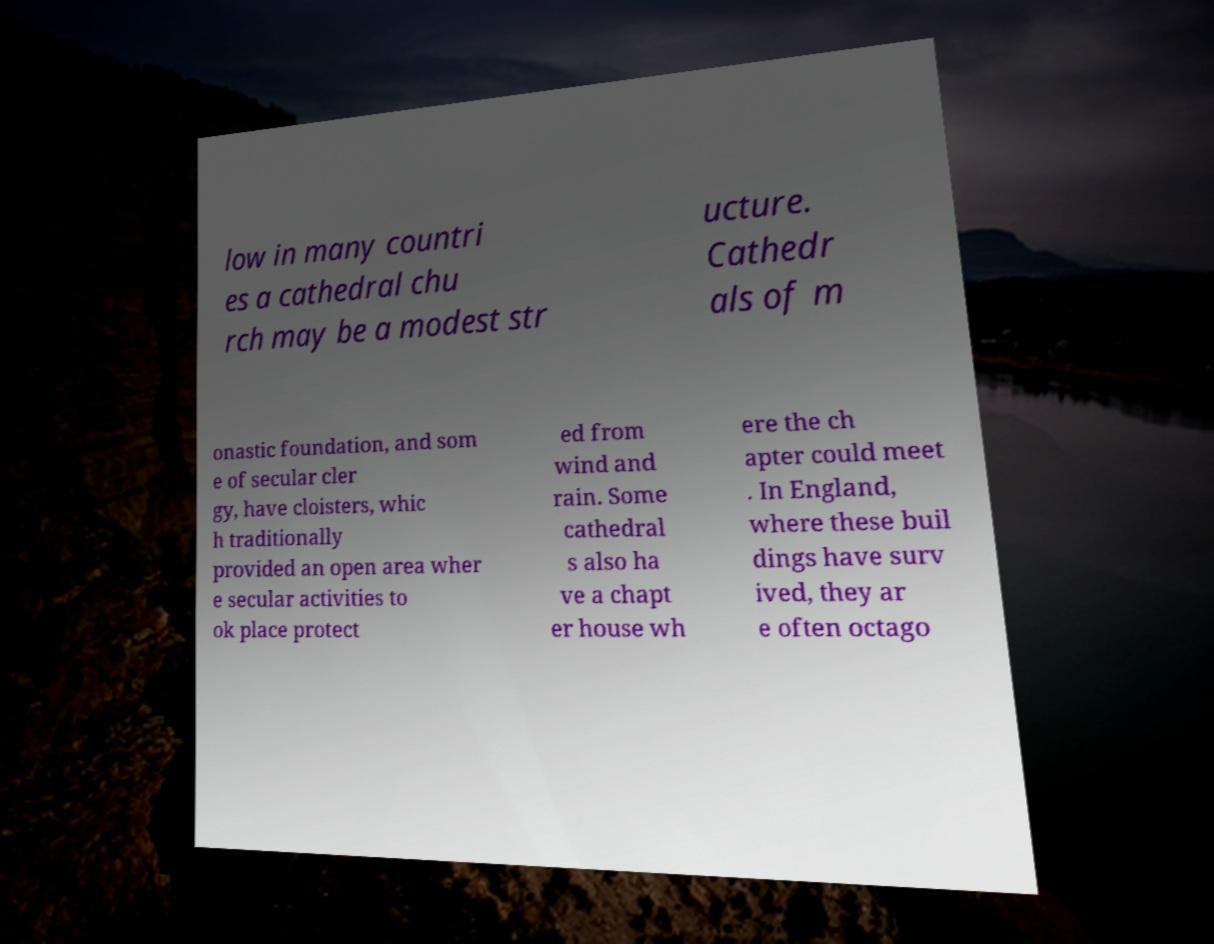Please identify and transcribe the text found in this image. low in many countri es a cathedral chu rch may be a modest str ucture. Cathedr als of m onastic foundation, and som e of secular cler gy, have cloisters, whic h traditionally provided an open area wher e secular activities to ok place protect ed from wind and rain. Some cathedral s also ha ve a chapt er house wh ere the ch apter could meet . In England, where these buil dings have surv ived, they ar e often octago 